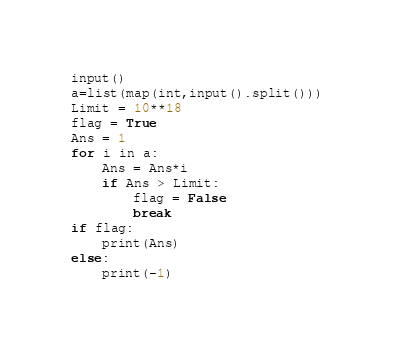<code> <loc_0><loc_0><loc_500><loc_500><_Python_>input()
a=list(map(int,input().split()))
Limit = 10**18
flag = True
Ans = 1
for i in a:
    Ans = Ans*i
    if Ans > Limit:
        flag = False
        break
if flag:
    print(Ans)
else:
    print(-1)</code> 